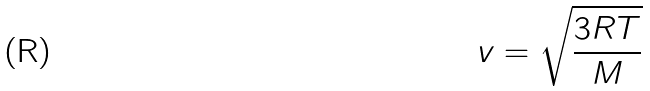<formula> <loc_0><loc_0><loc_500><loc_500>v = \sqrt { \frac { 3 R T } { M } }</formula> 